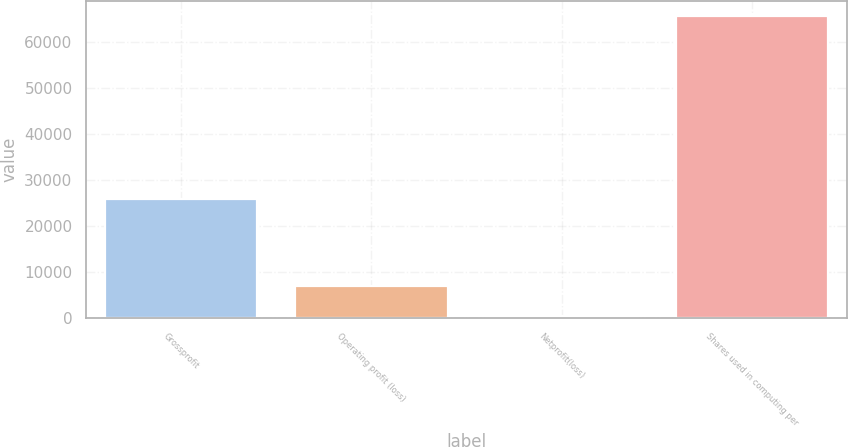Convert chart. <chart><loc_0><loc_0><loc_500><loc_500><bar_chart><fcel>Grossprofit<fcel>Operating profit (loss)<fcel>Netprofit(loss)<fcel>Shares used in computing per<nl><fcel>25812<fcel>6957.2<fcel>557<fcel>65491.2<nl></chart> 